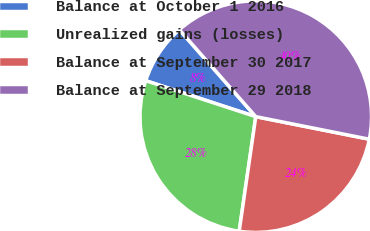<chart> <loc_0><loc_0><loc_500><loc_500><pie_chart><fcel>Balance at October 1 2016<fcel>Unrealized gains (losses)<fcel>Balance at September 30 2017<fcel>Balance at September 29 2018<nl><fcel>8.5%<fcel>27.74%<fcel>24.16%<fcel>39.6%<nl></chart> 